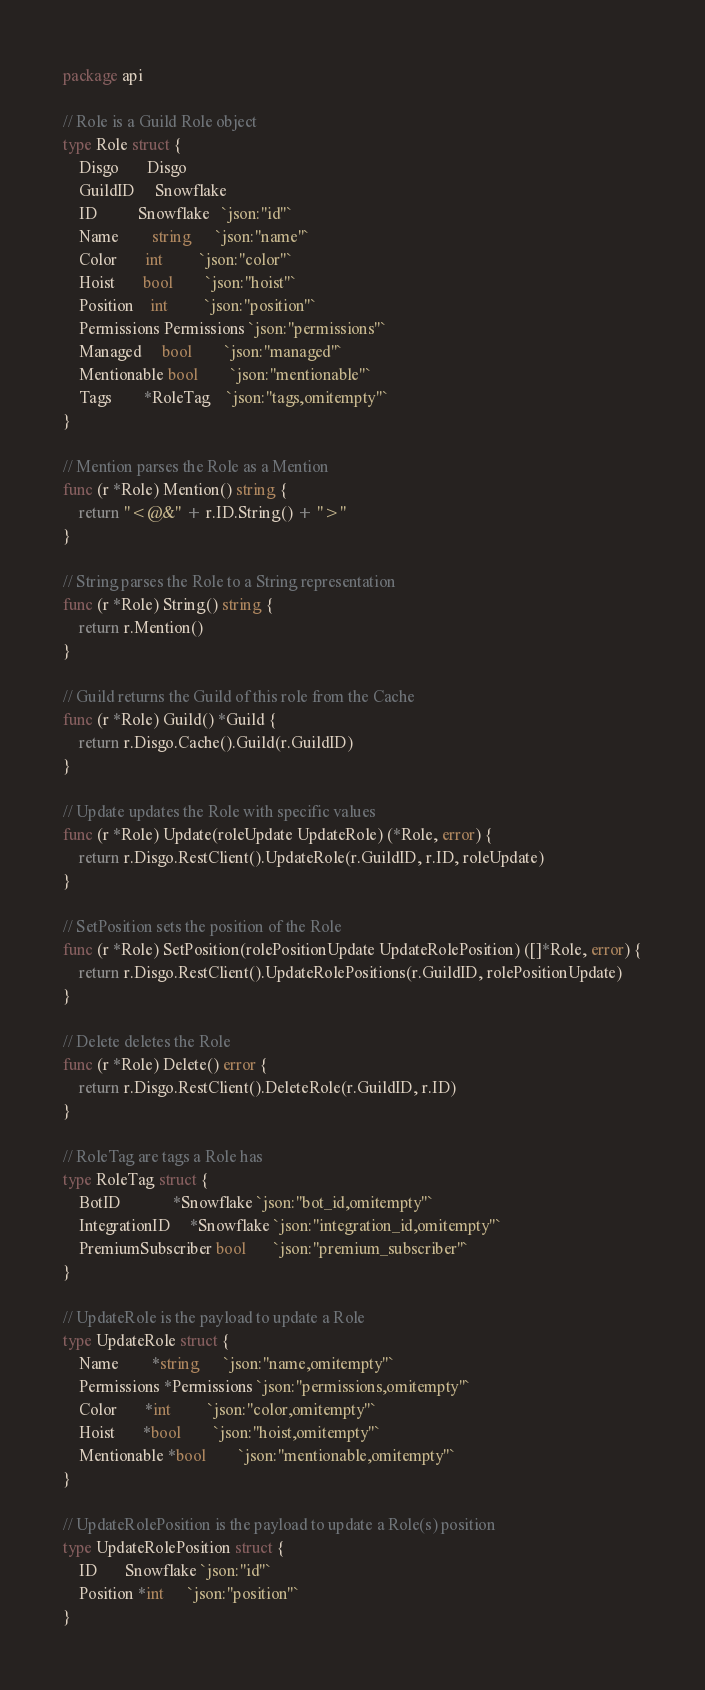<code> <loc_0><loc_0><loc_500><loc_500><_Go_>package api

// Role is a Guild Role object
type Role struct {
	Disgo       Disgo
	GuildID     Snowflake
	ID          Snowflake   `json:"id"`
	Name        string      `json:"name"`
	Color       int         `json:"color"`
	Hoist       bool        `json:"hoist"`
	Position    int         `json:"position"`
	Permissions Permissions `json:"permissions"`
	Managed     bool        `json:"managed"`
	Mentionable bool        `json:"mentionable"`
	Tags        *RoleTag    `json:"tags,omitempty"`
}

// Mention parses the Role as a Mention
func (r *Role) Mention() string {
	return "<@&" + r.ID.String() + ">"
}

// String parses the Role to a String representation
func (r *Role) String() string {
	return r.Mention()
}

// Guild returns the Guild of this role from the Cache
func (r *Role) Guild() *Guild {
	return r.Disgo.Cache().Guild(r.GuildID)
}

// Update updates the Role with specific values
func (r *Role) Update(roleUpdate UpdateRole) (*Role, error) {
	return r.Disgo.RestClient().UpdateRole(r.GuildID, r.ID, roleUpdate)
}

// SetPosition sets the position of the Role
func (r *Role) SetPosition(rolePositionUpdate UpdateRolePosition) ([]*Role, error) {
	return r.Disgo.RestClient().UpdateRolePositions(r.GuildID, rolePositionUpdate)
}

// Delete deletes the Role
func (r *Role) Delete() error {
	return r.Disgo.RestClient().DeleteRole(r.GuildID, r.ID)
}

// RoleTag are tags a Role has
type RoleTag struct {
	BotID             *Snowflake `json:"bot_id,omitempty"`
	IntegrationID     *Snowflake `json:"integration_id,omitempty"`
	PremiumSubscriber bool       `json:"premium_subscriber"`
}

// UpdateRole is the payload to update a Role
type UpdateRole struct {
	Name        *string      `json:"name,omitempty"`
	Permissions *Permissions `json:"permissions,omitempty"`
	Color       *int         `json:"color,omitempty"`
	Hoist       *bool        `json:"hoist,omitempty"`
	Mentionable *bool        `json:"mentionable,omitempty"`
}

// UpdateRolePosition is the payload to update a Role(s) position
type UpdateRolePosition struct {
	ID       Snowflake `json:"id"`
	Position *int      `json:"position"`
}
</code> 